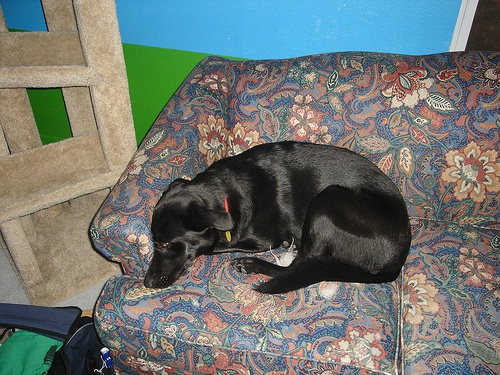Describe the objects in this image and their specific colors. I can see couch in blue, gray, black, and darkgray tones, dog in blue, black, and gray tones, and suitcase in blue, black, teal, and navy tones in this image. 